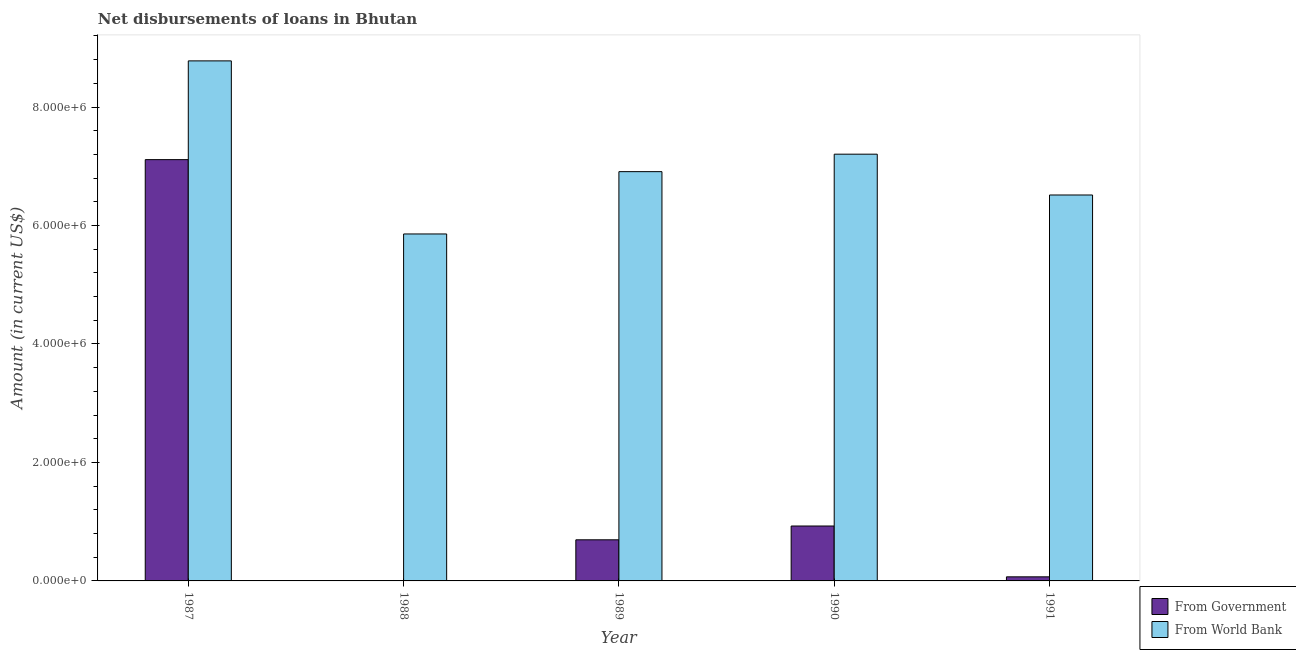How many groups of bars are there?
Provide a succinct answer. 5. How many bars are there on the 4th tick from the left?
Your response must be concise. 2. What is the net disbursements of loan from government in 1989?
Offer a terse response. 6.94e+05. Across all years, what is the maximum net disbursements of loan from world bank?
Provide a short and direct response. 8.78e+06. Across all years, what is the minimum net disbursements of loan from government?
Make the answer very short. 7000. In which year was the net disbursements of loan from world bank maximum?
Ensure brevity in your answer.  1987. In which year was the net disbursements of loan from government minimum?
Your answer should be compact. 1988. What is the total net disbursements of loan from government in the graph?
Provide a short and direct response. 8.81e+06. What is the difference between the net disbursements of loan from government in 1988 and that in 1990?
Your answer should be very brief. -9.20e+05. What is the difference between the net disbursements of loan from world bank in 1988 and the net disbursements of loan from government in 1989?
Provide a succinct answer. -1.05e+06. What is the average net disbursements of loan from world bank per year?
Your response must be concise. 7.05e+06. In the year 1988, what is the difference between the net disbursements of loan from world bank and net disbursements of loan from government?
Provide a succinct answer. 0. In how many years, is the net disbursements of loan from world bank greater than 1200000 US$?
Your answer should be compact. 5. What is the ratio of the net disbursements of loan from world bank in 1989 to that in 1991?
Provide a succinct answer. 1.06. Is the difference between the net disbursements of loan from world bank in 1988 and 1991 greater than the difference between the net disbursements of loan from government in 1988 and 1991?
Keep it short and to the point. No. What is the difference between the highest and the second highest net disbursements of loan from world bank?
Offer a terse response. 1.58e+06. What is the difference between the highest and the lowest net disbursements of loan from government?
Give a very brief answer. 7.10e+06. What does the 1st bar from the left in 1989 represents?
Keep it short and to the point. From Government. What does the 2nd bar from the right in 1990 represents?
Provide a succinct answer. From Government. How many bars are there?
Your response must be concise. 10. Are all the bars in the graph horizontal?
Ensure brevity in your answer.  No. What is the difference between two consecutive major ticks on the Y-axis?
Ensure brevity in your answer.  2.00e+06. Where does the legend appear in the graph?
Your answer should be compact. Bottom right. How many legend labels are there?
Provide a short and direct response. 2. How are the legend labels stacked?
Ensure brevity in your answer.  Vertical. What is the title of the graph?
Ensure brevity in your answer.  Net disbursements of loans in Bhutan. What is the label or title of the Y-axis?
Ensure brevity in your answer.  Amount (in current US$). What is the Amount (in current US$) of From Government in 1987?
Your answer should be compact. 7.11e+06. What is the Amount (in current US$) in From World Bank in 1987?
Your response must be concise. 8.78e+06. What is the Amount (in current US$) in From Government in 1988?
Make the answer very short. 7000. What is the Amount (in current US$) in From World Bank in 1988?
Your answer should be compact. 5.86e+06. What is the Amount (in current US$) of From Government in 1989?
Provide a short and direct response. 6.94e+05. What is the Amount (in current US$) of From World Bank in 1989?
Keep it short and to the point. 6.91e+06. What is the Amount (in current US$) in From Government in 1990?
Provide a succinct answer. 9.27e+05. What is the Amount (in current US$) in From World Bank in 1990?
Provide a succinct answer. 7.20e+06. What is the Amount (in current US$) of From Government in 1991?
Provide a short and direct response. 6.90e+04. What is the Amount (in current US$) in From World Bank in 1991?
Make the answer very short. 6.52e+06. Across all years, what is the maximum Amount (in current US$) of From Government?
Your answer should be compact. 7.11e+06. Across all years, what is the maximum Amount (in current US$) in From World Bank?
Ensure brevity in your answer.  8.78e+06. Across all years, what is the minimum Amount (in current US$) of From Government?
Keep it short and to the point. 7000. Across all years, what is the minimum Amount (in current US$) of From World Bank?
Ensure brevity in your answer.  5.86e+06. What is the total Amount (in current US$) of From Government in the graph?
Make the answer very short. 8.81e+06. What is the total Amount (in current US$) of From World Bank in the graph?
Your answer should be very brief. 3.53e+07. What is the difference between the Amount (in current US$) in From Government in 1987 and that in 1988?
Your answer should be very brief. 7.10e+06. What is the difference between the Amount (in current US$) of From World Bank in 1987 and that in 1988?
Make the answer very short. 2.92e+06. What is the difference between the Amount (in current US$) in From Government in 1987 and that in 1989?
Give a very brief answer. 6.42e+06. What is the difference between the Amount (in current US$) in From World Bank in 1987 and that in 1989?
Offer a terse response. 1.87e+06. What is the difference between the Amount (in current US$) of From Government in 1987 and that in 1990?
Provide a succinct answer. 6.18e+06. What is the difference between the Amount (in current US$) of From World Bank in 1987 and that in 1990?
Your response must be concise. 1.58e+06. What is the difference between the Amount (in current US$) in From Government in 1987 and that in 1991?
Your answer should be very brief. 7.04e+06. What is the difference between the Amount (in current US$) in From World Bank in 1987 and that in 1991?
Keep it short and to the point. 2.26e+06. What is the difference between the Amount (in current US$) of From Government in 1988 and that in 1989?
Offer a terse response. -6.87e+05. What is the difference between the Amount (in current US$) of From World Bank in 1988 and that in 1989?
Ensure brevity in your answer.  -1.05e+06. What is the difference between the Amount (in current US$) of From Government in 1988 and that in 1990?
Your answer should be compact. -9.20e+05. What is the difference between the Amount (in current US$) of From World Bank in 1988 and that in 1990?
Give a very brief answer. -1.35e+06. What is the difference between the Amount (in current US$) in From Government in 1988 and that in 1991?
Your answer should be very brief. -6.20e+04. What is the difference between the Amount (in current US$) of From World Bank in 1988 and that in 1991?
Make the answer very short. -6.58e+05. What is the difference between the Amount (in current US$) of From Government in 1989 and that in 1990?
Offer a very short reply. -2.33e+05. What is the difference between the Amount (in current US$) in From World Bank in 1989 and that in 1990?
Keep it short and to the point. -2.95e+05. What is the difference between the Amount (in current US$) of From Government in 1989 and that in 1991?
Offer a very short reply. 6.25e+05. What is the difference between the Amount (in current US$) in From World Bank in 1989 and that in 1991?
Offer a very short reply. 3.94e+05. What is the difference between the Amount (in current US$) of From Government in 1990 and that in 1991?
Give a very brief answer. 8.58e+05. What is the difference between the Amount (in current US$) in From World Bank in 1990 and that in 1991?
Keep it short and to the point. 6.89e+05. What is the difference between the Amount (in current US$) in From Government in 1987 and the Amount (in current US$) in From World Bank in 1988?
Provide a short and direct response. 1.26e+06. What is the difference between the Amount (in current US$) in From Government in 1987 and the Amount (in current US$) in From World Bank in 1989?
Offer a terse response. 2.03e+05. What is the difference between the Amount (in current US$) of From Government in 1987 and the Amount (in current US$) of From World Bank in 1990?
Your response must be concise. -9.20e+04. What is the difference between the Amount (in current US$) of From Government in 1987 and the Amount (in current US$) of From World Bank in 1991?
Your answer should be compact. 5.97e+05. What is the difference between the Amount (in current US$) of From Government in 1988 and the Amount (in current US$) of From World Bank in 1989?
Your answer should be very brief. -6.90e+06. What is the difference between the Amount (in current US$) in From Government in 1988 and the Amount (in current US$) in From World Bank in 1990?
Provide a succinct answer. -7.20e+06. What is the difference between the Amount (in current US$) in From Government in 1988 and the Amount (in current US$) in From World Bank in 1991?
Give a very brief answer. -6.51e+06. What is the difference between the Amount (in current US$) of From Government in 1989 and the Amount (in current US$) of From World Bank in 1990?
Make the answer very short. -6.51e+06. What is the difference between the Amount (in current US$) in From Government in 1989 and the Amount (in current US$) in From World Bank in 1991?
Ensure brevity in your answer.  -5.82e+06. What is the difference between the Amount (in current US$) in From Government in 1990 and the Amount (in current US$) in From World Bank in 1991?
Your response must be concise. -5.59e+06. What is the average Amount (in current US$) in From Government per year?
Your answer should be very brief. 1.76e+06. What is the average Amount (in current US$) of From World Bank per year?
Your answer should be compact. 7.05e+06. In the year 1987, what is the difference between the Amount (in current US$) of From Government and Amount (in current US$) of From World Bank?
Keep it short and to the point. -1.67e+06. In the year 1988, what is the difference between the Amount (in current US$) of From Government and Amount (in current US$) of From World Bank?
Ensure brevity in your answer.  -5.85e+06. In the year 1989, what is the difference between the Amount (in current US$) of From Government and Amount (in current US$) of From World Bank?
Your response must be concise. -6.22e+06. In the year 1990, what is the difference between the Amount (in current US$) in From Government and Amount (in current US$) in From World Bank?
Your answer should be very brief. -6.28e+06. In the year 1991, what is the difference between the Amount (in current US$) of From Government and Amount (in current US$) of From World Bank?
Make the answer very short. -6.45e+06. What is the ratio of the Amount (in current US$) of From Government in 1987 to that in 1988?
Provide a succinct answer. 1016. What is the ratio of the Amount (in current US$) of From World Bank in 1987 to that in 1988?
Keep it short and to the point. 1.5. What is the ratio of the Amount (in current US$) of From Government in 1987 to that in 1989?
Your answer should be compact. 10.25. What is the ratio of the Amount (in current US$) of From World Bank in 1987 to that in 1989?
Give a very brief answer. 1.27. What is the ratio of the Amount (in current US$) of From Government in 1987 to that in 1990?
Provide a succinct answer. 7.67. What is the ratio of the Amount (in current US$) of From World Bank in 1987 to that in 1990?
Ensure brevity in your answer.  1.22. What is the ratio of the Amount (in current US$) in From Government in 1987 to that in 1991?
Keep it short and to the point. 103.07. What is the ratio of the Amount (in current US$) of From World Bank in 1987 to that in 1991?
Make the answer very short. 1.35. What is the ratio of the Amount (in current US$) of From Government in 1988 to that in 1989?
Your response must be concise. 0.01. What is the ratio of the Amount (in current US$) of From World Bank in 1988 to that in 1989?
Your answer should be very brief. 0.85. What is the ratio of the Amount (in current US$) of From Government in 1988 to that in 1990?
Offer a terse response. 0.01. What is the ratio of the Amount (in current US$) of From World Bank in 1988 to that in 1990?
Offer a terse response. 0.81. What is the ratio of the Amount (in current US$) in From Government in 1988 to that in 1991?
Offer a terse response. 0.1. What is the ratio of the Amount (in current US$) of From World Bank in 1988 to that in 1991?
Make the answer very short. 0.9. What is the ratio of the Amount (in current US$) in From Government in 1989 to that in 1990?
Make the answer very short. 0.75. What is the ratio of the Amount (in current US$) of From World Bank in 1989 to that in 1990?
Your response must be concise. 0.96. What is the ratio of the Amount (in current US$) of From Government in 1989 to that in 1991?
Ensure brevity in your answer.  10.06. What is the ratio of the Amount (in current US$) in From World Bank in 1989 to that in 1991?
Your response must be concise. 1.06. What is the ratio of the Amount (in current US$) in From Government in 1990 to that in 1991?
Your answer should be very brief. 13.43. What is the ratio of the Amount (in current US$) of From World Bank in 1990 to that in 1991?
Keep it short and to the point. 1.11. What is the difference between the highest and the second highest Amount (in current US$) of From Government?
Keep it short and to the point. 6.18e+06. What is the difference between the highest and the second highest Amount (in current US$) of From World Bank?
Make the answer very short. 1.58e+06. What is the difference between the highest and the lowest Amount (in current US$) of From Government?
Make the answer very short. 7.10e+06. What is the difference between the highest and the lowest Amount (in current US$) in From World Bank?
Offer a very short reply. 2.92e+06. 